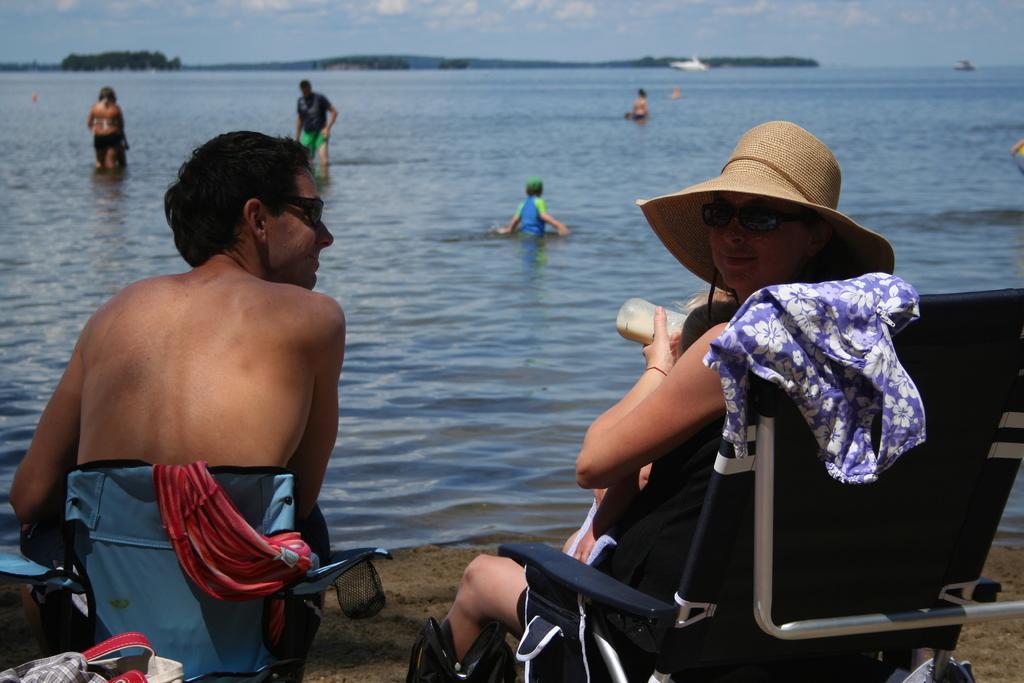How would you summarize this image in a sentence or two? In this image I can see a woman is sitting on the chair, she wore hat. In the middle few people are there in this water. At the top there is the sky. 